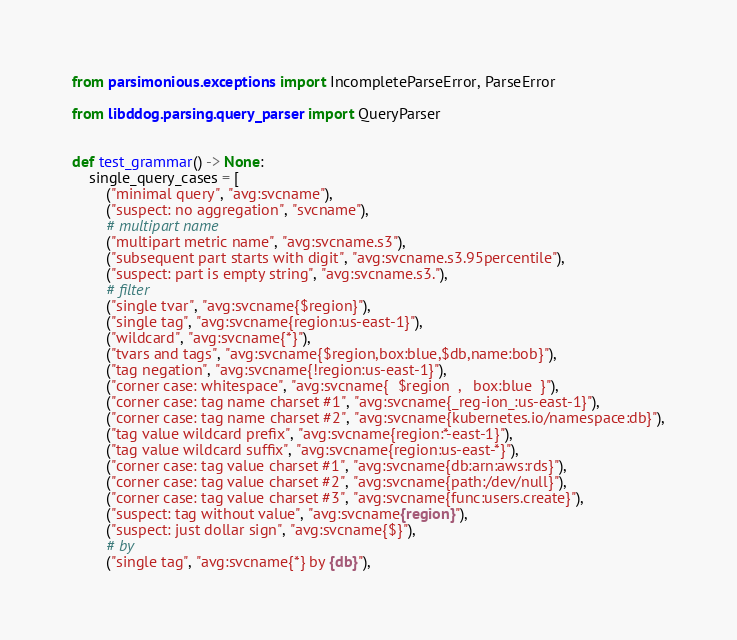Convert code to text. <code><loc_0><loc_0><loc_500><loc_500><_Python_>from parsimonious.exceptions import IncompleteParseError, ParseError

from libddog.parsing.query_parser import QueryParser


def test_grammar() -> None:
    single_query_cases = [
        ("minimal query", "avg:svcname"),
        ("suspect: no aggregation", "svcname"),
        # multipart name
        ("multipart metric name", "avg:svcname.s3"),
        ("subsequent part starts with digit", "avg:svcname.s3.95percentile"),
        ("suspect: part is empty string", "avg:svcname.s3."),
        # filter
        ("single tvar", "avg:svcname{$region}"),
        ("single tag", "avg:svcname{region:us-east-1}"),
        ("wildcard", "avg:svcname{*}"),
        ("tvars and tags", "avg:svcname{$region,box:blue,$db,name:bob}"),
        ("tag negation", "avg:svcname{!region:us-east-1}"),
        ("corner case: whitespace", "avg:svcname{  $region  ,   box:blue  }"),
        ("corner case: tag name charset #1", "avg:svcname{_reg-ion_:us-east-1}"),
        ("corner case: tag name charset #2", "avg:svcname{kubernetes.io/namespace:db}"),
        ("tag value wildcard prefix", "avg:svcname{region:*-east-1}"),
        ("tag value wildcard suffix", "avg:svcname{region:us-east-*}"),
        ("corner case: tag value charset #1", "avg:svcname{db:arn:aws:rds}"),
        ("corner case: tag value charset #2", "avg:svcname{path:/dev/null}"),
        ("corner case: tag value charset #3", "avg:svcname{func:users.create}"),
        ("suspect: tag without value", "avg:svcname{region}"),
        ("suspect: just dollar sign", "avg:svcname{$}"),
        # by
        ("single tag", "avg:svcname{*} by {db}"),</code> 